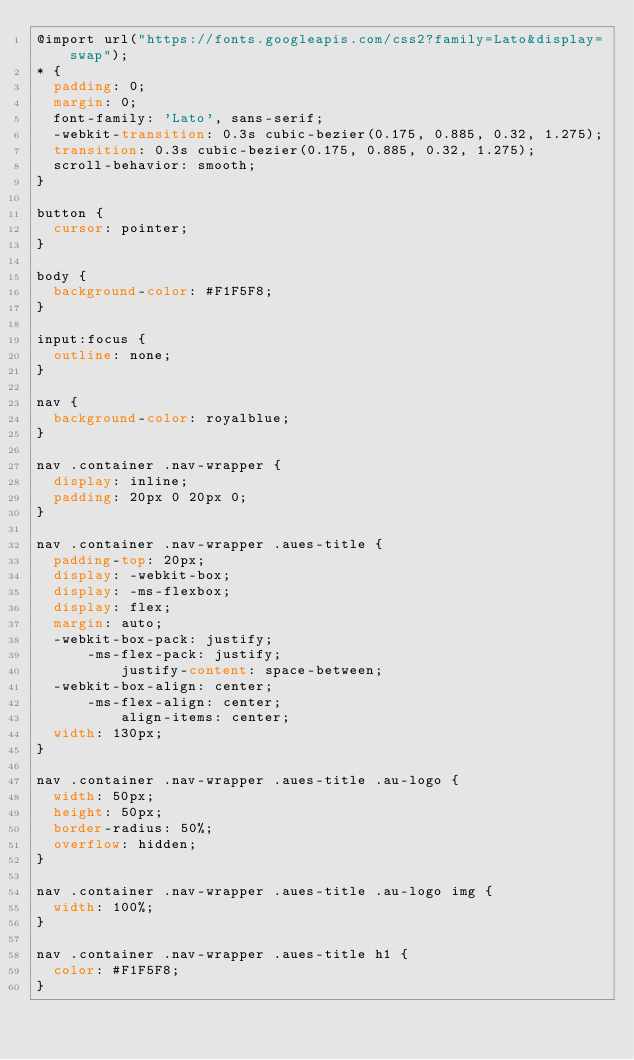Convert code to text. <code><loc_0><loc_0><loc_500><loc_500><_CSS_>@import url("https://fonts.googleapis.com/css2?family=Lato&display=swap");
* {
  padding: 0;
  margin: 0;
  font-family: 'Lato', sans-serif;
  -webkit-transition: 0.3s cubic-bezier(0.175, 0.885, 0.32, 1.275);
  transition: 0.3s cubic-bezier(0.175, 0.885, 0.32, 1.275);
  scroll-behavior: smooth;
}

button {
  cursor: pointer;
}

body {
  background-color: #F1F5F8;
}

input:focus {
  outline: none;
}

nav {
  background-color: royalblue;
}

nav .container .nav-wrapper {
  display: inline;
  padding: 20px 0 20px 0;
}

nav .container .nav-wrapper .aues-title {
  padding-top: 20px;
  display: -webkit-box;
  display: -ms-flexbox;
  display: flex;
  margin: auto;
  -webkit-box-pack: justify;
      -ms-flex-pack: justify;
          justify-content: space-between;
  -webkit-box-align: center;
      -ms-flex-align: center;
          align-items: center;
  width: 130px;
}

nav .container .nav-wrapper .aues-title .au-logo {
  width: 50px;
  height: 50px;
  border-radius: 50%;
  overflow: hidden;
}

nav .container .nav-wrapper .aues-title .au-logo img {
  width: 100%;
}

nav .container .nav-wrapper .aues-title h1 {
  color: #F1F5F8;
}
</code> 